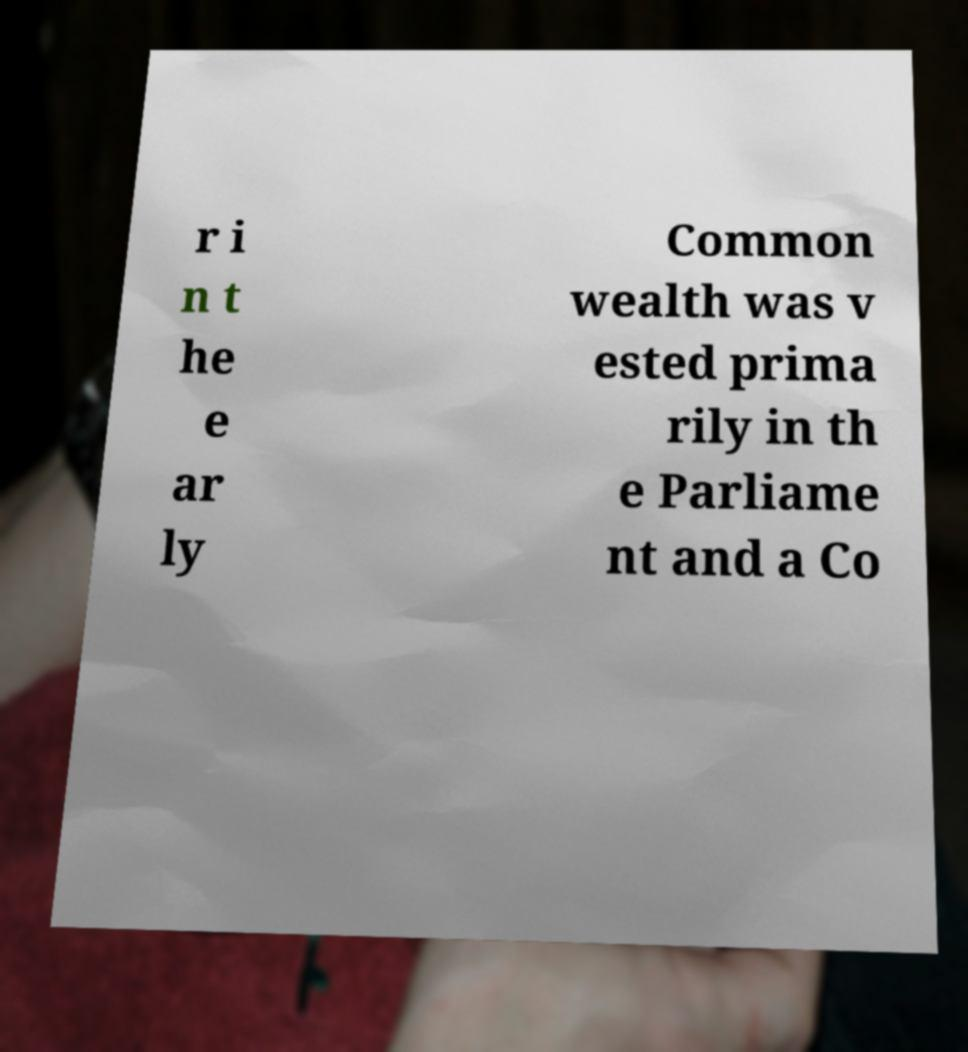Can you accurately transcribe the text from the provided image for me? r i n t he e ar ly Common wealth was v ested prima rily in th e Parliame nt and a Co 